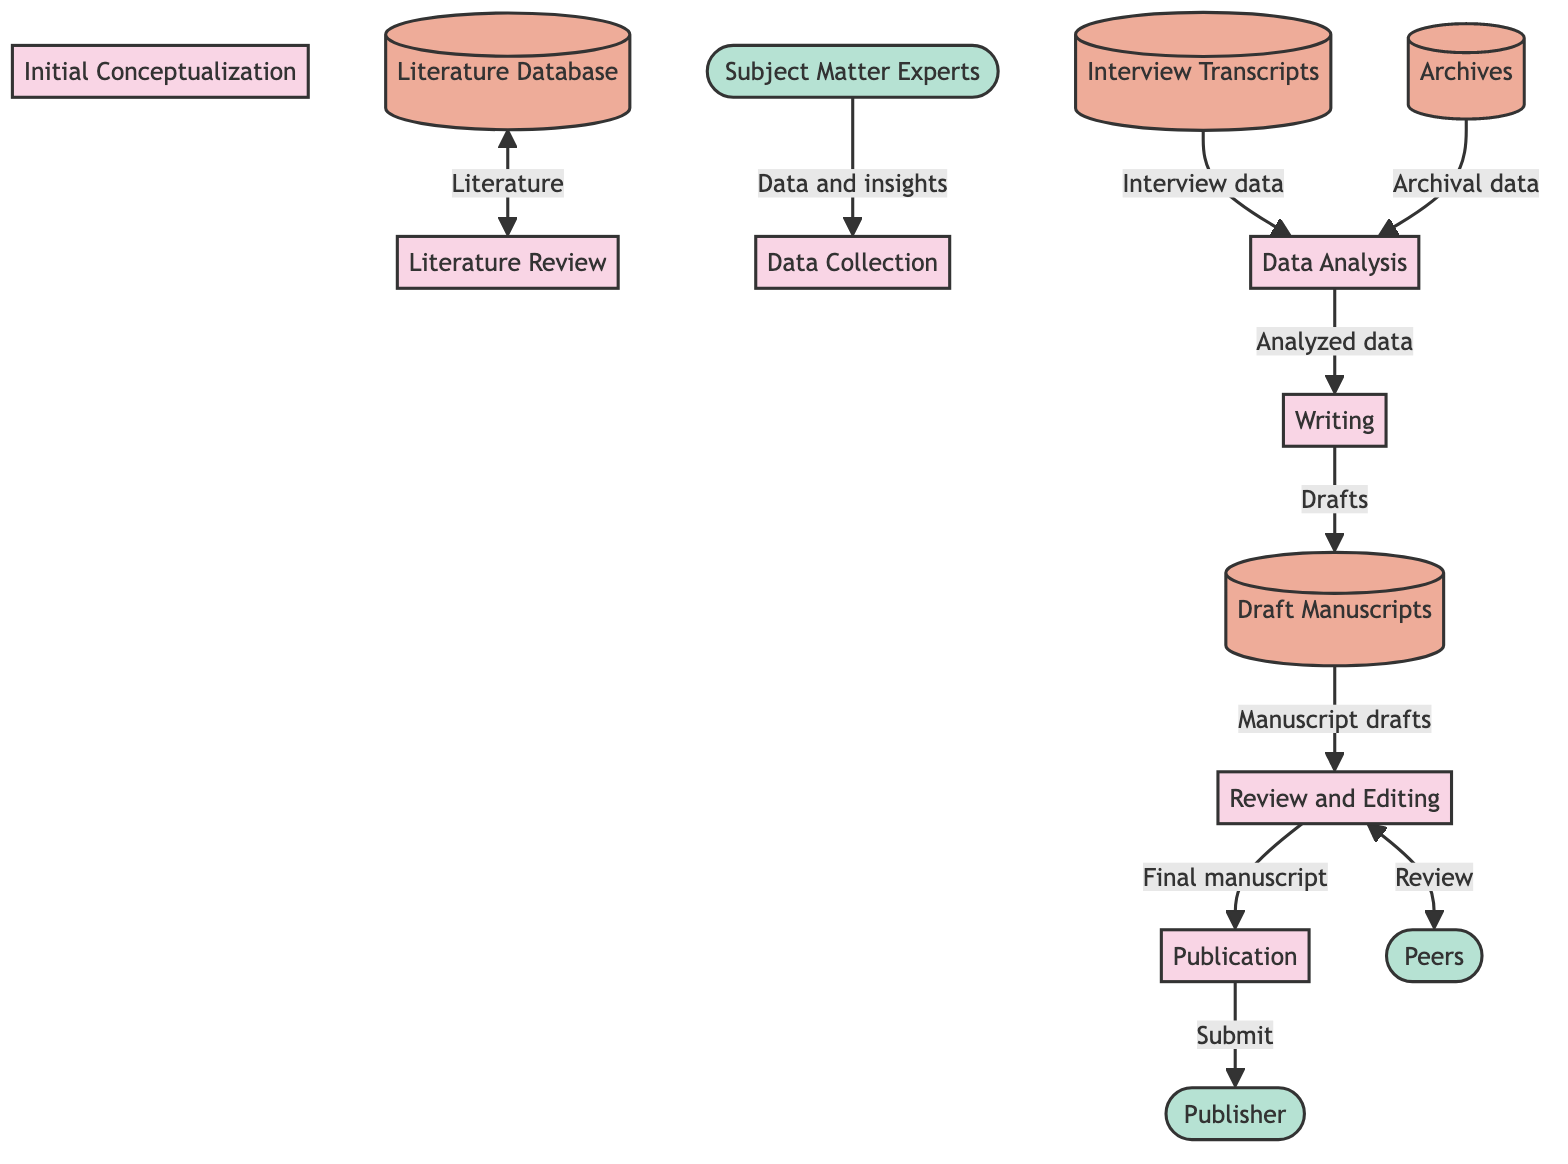What is the first process in the diagram? The first process in the diagram is labeled as "P1," which corresponds to "Initial Conceptualization."
Answer: Initial Conceptualization How many processes are represented in the diagram? The diagram displays a total of 7 processes labeled P1 through P7.
Answer: 7 Which data store provides literature for the Literature Review process? The Literature Review process (P2) receives literature from the data store labeled as "DS1," which stands for "Literature Database."
Answer: Literature Database What is the data flow from the Review and Editing process to the Peers? The Review and Editing process (P6) circulates the manuscript for peer review to the external entity labeled as "EE2," identified as "Peers."
Answer: Circulate manuscript for peer review Which process follows Data Analysis in the lifecycle? After completing the Data Analysis process (P4), the next step in the lifecycle is the Writing process (P5).
Answer: Writing What type of external entity contributes insights to the Data Collection process? The Data Collection process (P3) relies on insights gathered from the external entity labeled "EE1," referred to as "Subject Matter Experts."
Answer: Subject Matter Experts What is the last process before the manuscript is submitted to a publisher? The last process that occurs before submitting the manuscript is the Publication process (P7).
Answer: Publication What feedback flows into the Review and Editing process? Feedback from the Peers, identified by the external entity "EE2," flows back into the Review and Editing process (P6) for revisions.
Answer: Feedback from peers 